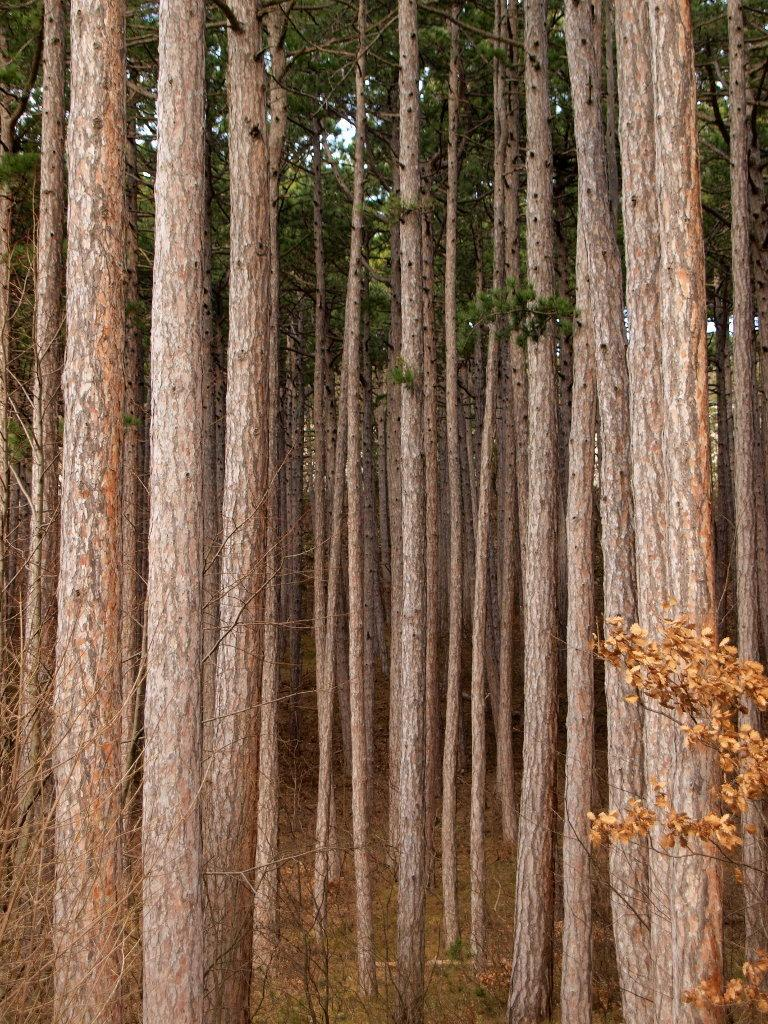What type of vegetation is present in the image? There are many trees in the image. Can you describe the appearance of the trees? The trees have leaves visible in the image. What is the color of the sky in the image? The sky is white in the image. What type of tax is being discussed in the image? There is no discussion of tax in the image; it primarily features trees and a white sky. 